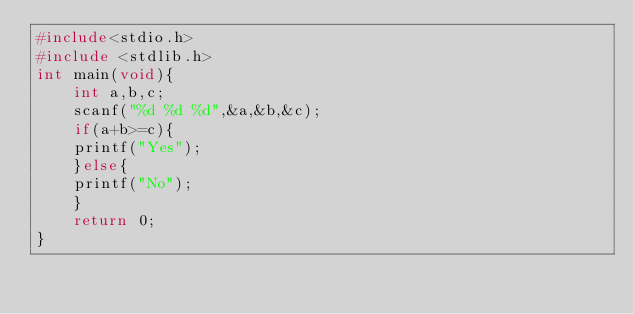<code> <loc_0><loc_0><loc_500><loc_500><_C++_>#include<stdio.h>
#include <stdlib.h>
int main(void){
	int a,b,c;
	scanf("%d %d %d",&a,&b,&c);
	if(a+b>=c){
	printf("Yes");
	}else{
	printf("No");
	}
	return 0;
}</code> 